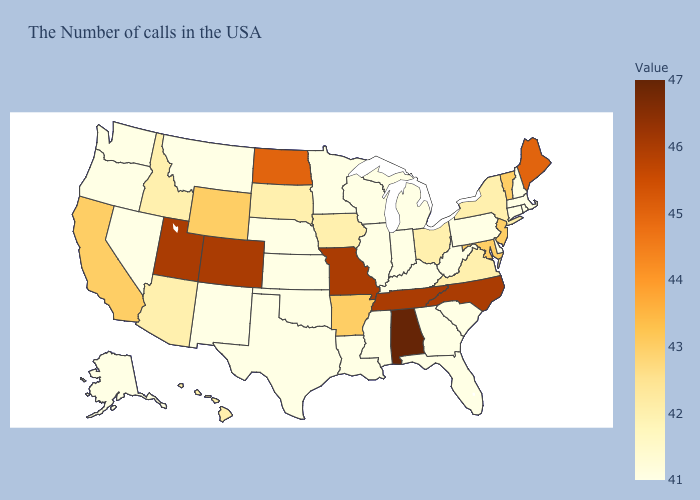Which states have the lowest value in the USA?
Answer briefly. Massachusetts, Rhode Island, New Hampshire, Connecticut, Delaware, Pennsylvania, South Carolina, West Virginia, Florida, Georgia, Michigan, Kentucky, Indiana, Wisconsin, Illinois, Mississippi, Louisiana, Minnesota, Kansas, Nebraska, Oklahoma, Texas, New Mexico, Montana, Nevada, Washington, Oregon, Alaska. Does Vermont have a lower value than Colorado?
Be succinct. Yes. Which states have the lowest value in the South?
Short answer required. Delaware, South Carolina, West Virginia, Florida, Georgia, Kentucky, Mississippi, Louisiana, Oklahoma, Texas. 